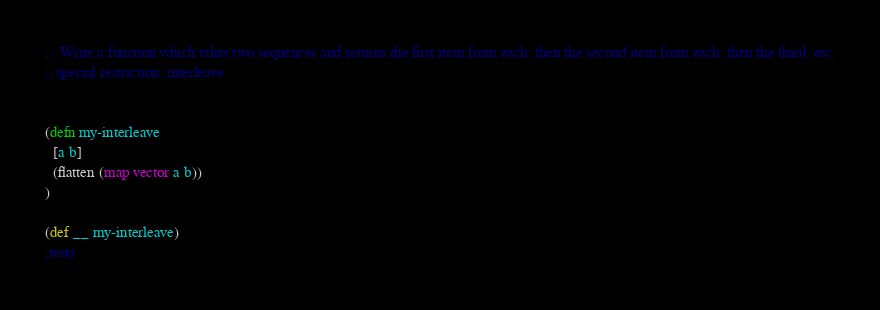Convert code to text. <code><loc_0><loc_0><loc_500><loc_500><_Clojure_>;;  Write a function which takes two sequences and returns the first item from each, then the second item from each, then the third, etc.
;; special restriction: interleave


(defn my-interleave
  [a b]
  (flatten (map vector a b))
)

(def __ my-interleave)
;tests
</code> 